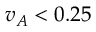<formula> <loc_0><loc_0><loc_500><loc_500>v _ { A } < 0 . 2 5</formula> 